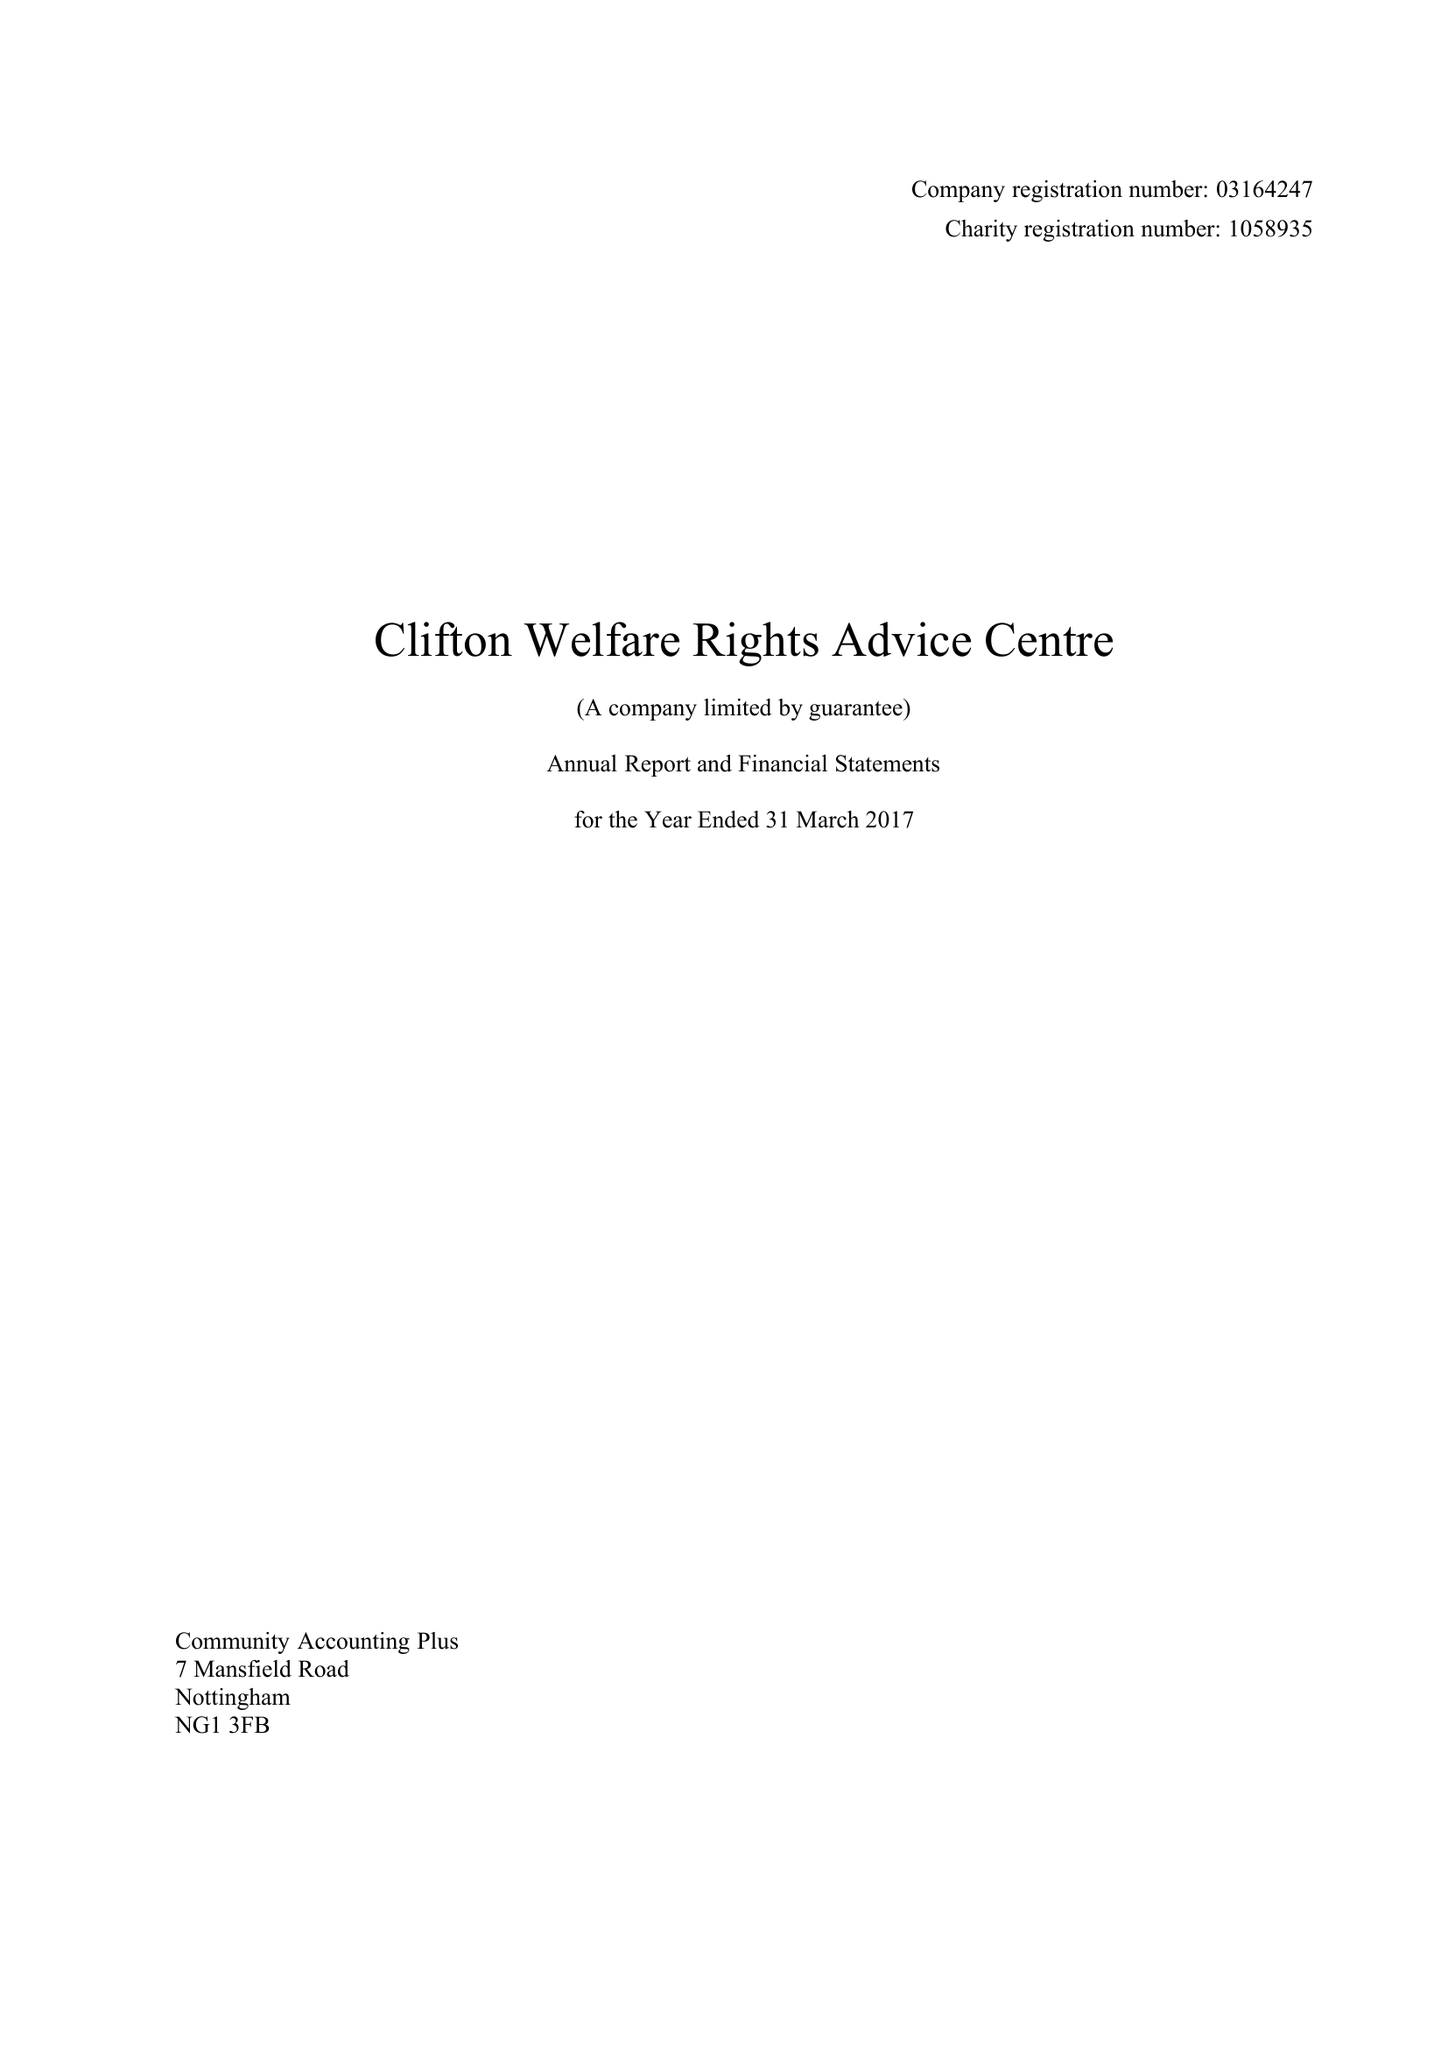What is the value for the address__street_line?
Answer the question using a single word or phrase. SOUTHCHURCH DRIVE 